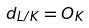<formula> <loc_0><loc_0><loc_500><loc_500>d _ { L / K } = O _ { K }</formula> 